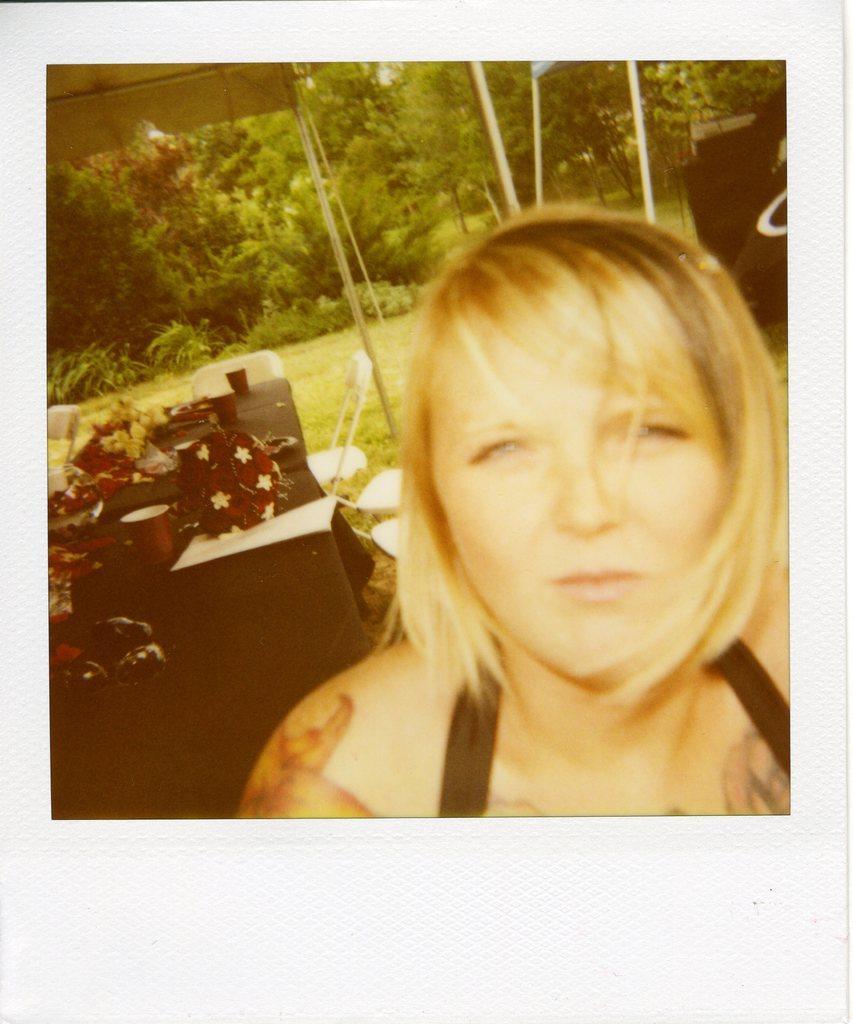Describe this image in one or two sentences. There is a woman, watching something. In the background, there are cups and other objects on the table, there are plants, trees and grass on the ground. 